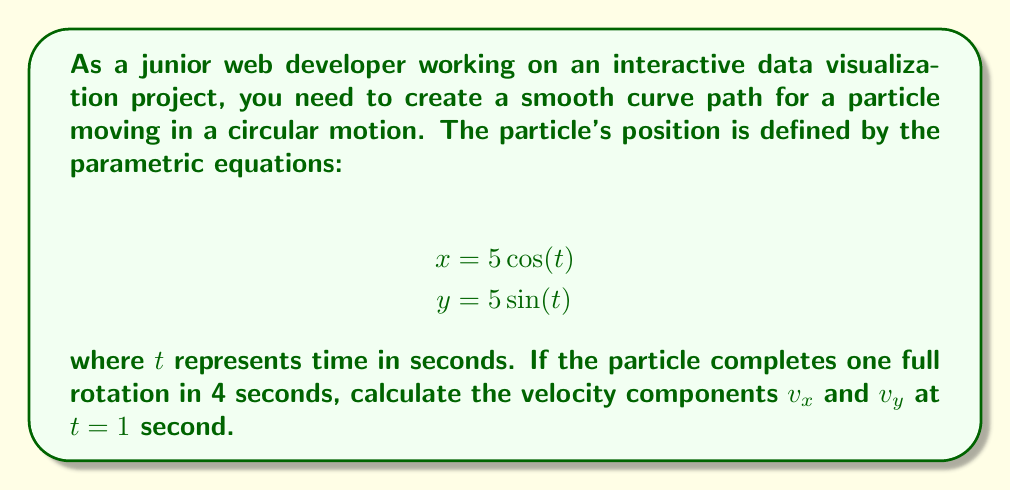Can you answer this question? To solve this problem, we'll follow these steps:

1. Understand the given parametric equations:
   $$x = 5\cos(t)$$
   $$y = 5\sin(t)$$
   These equations describe a circular path with a radius of 5 units.

2. Calculate the angular velocity $\omega$:
   The particle completes one full rotation (2π radians) in 4 seconds.
   $$\omega = \frac{2\pi}{4} = \frac{\pi}{2} \text{ rad/s}$$

3. Derive the velocity components:
   The velocity components are the derivatives of the position equations with respect to time:
   $$v_x = \frac{dx}{dt} = -5\omega\sin(\omega t)$$
   $$v_y = \frac{dy}{dt} = 5\omega\cos(\omega t)$$

4. Substitute the values:
   At $t = 1$ second, and $\omega = \frac{\pi}{2}$ rad/s:
   $$v_x = -5 \cdot \frac{\pi}{2} \cdot \sin(\frac{\pi}{2} \cdot 1) = -5 \cdot \frac{\pi}{2} \cdot 1 = -\frac{5\pi}{2}$$
   $$v_y = 5 \cdot \frac{\pi}{2} \cdot \cos(\frac{\pi}{2} \cdot 1) = 5 \cdot \frac{\pi}{2} \cdot 0 = 0$$

5. Express the final answer in vector notation:
   $$\vec{v} = \left(-\frac{5\pi}{2}, 0\right)$$
Answer: The velocity components at $t = 1$ second are:
$$v_x = -\frac{5\pi}{2} \text{ units/s}$$
$$v_y = 0 \text{ units/s}$$ 